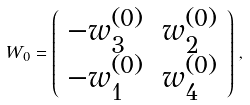<formula> <loc_0><loc_0><loc_500><loc_500>W _ { 0 } = \left ( \begin{array} { c c } - w _ { 3 } ^ { ( 0 ) } & w _ { 2 } ^ { ( 0 ) } \\ - w _ { 1 } ^ { ( 0 ) } & w _ { 4 } ^ { ( 0 ) } \\ \end{array} \right ) \, ,</formula> 